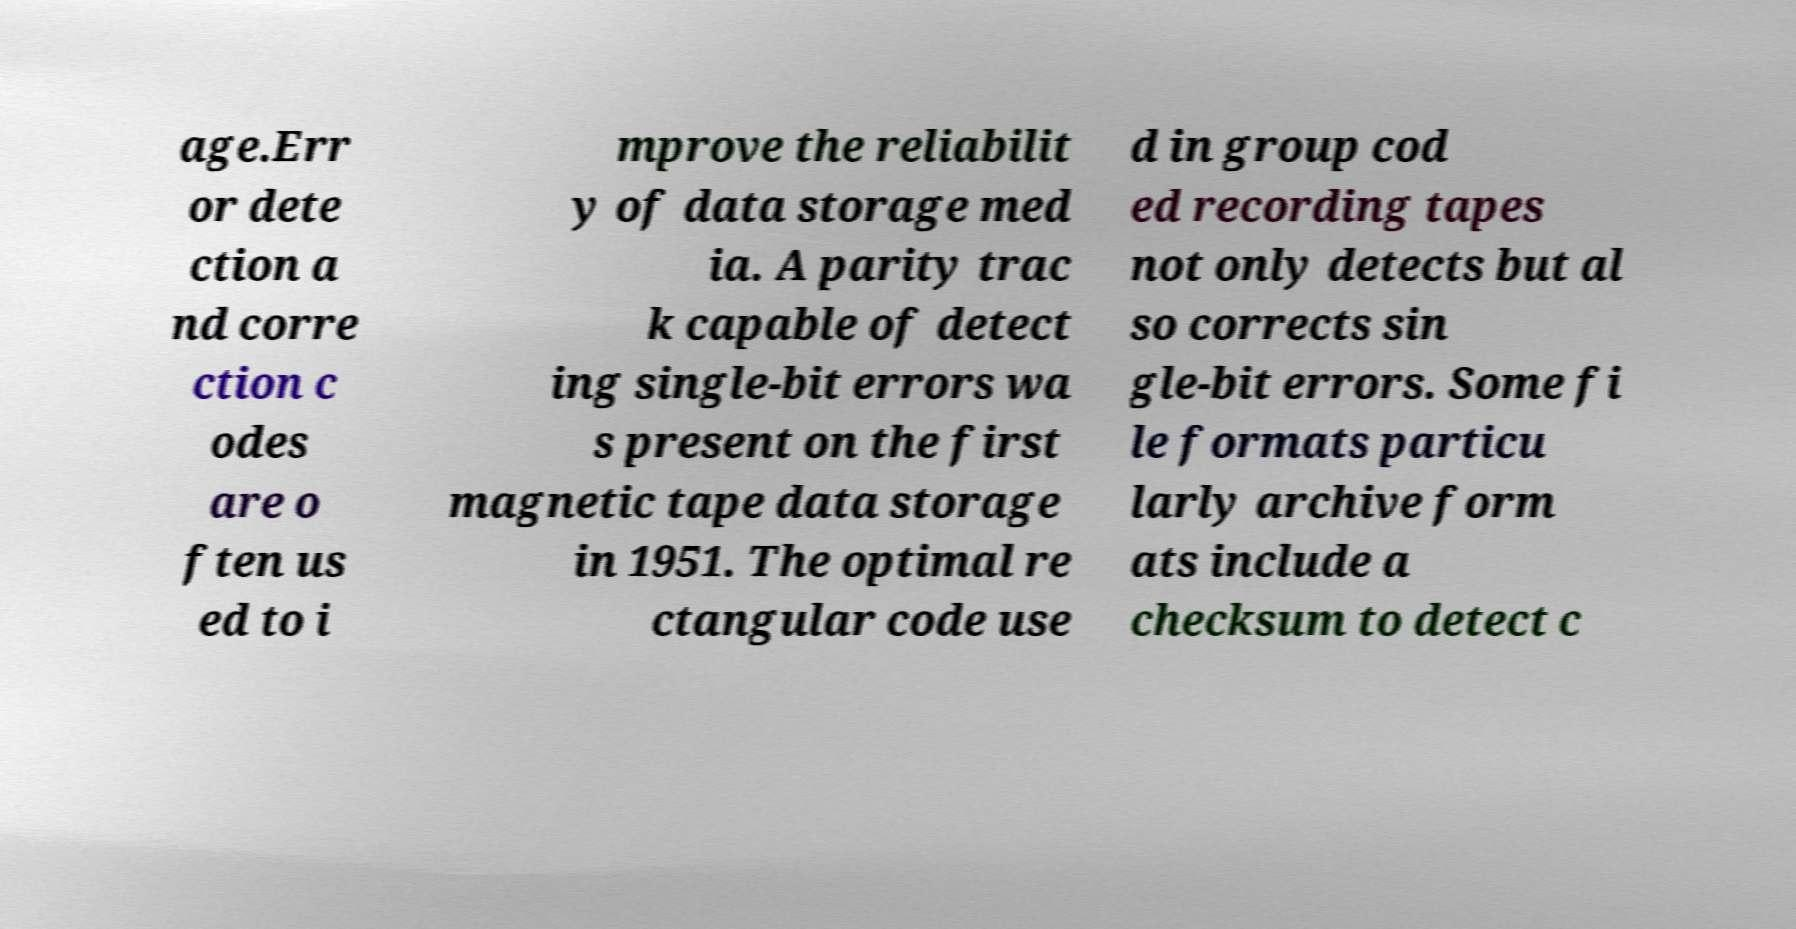I need the written content from this picture converted into text. Can you do that? age.Err or dete ction a nd corre ction c odes are o ften us ed to i mprove the reliabilit y of data storage med ia. A parity trac k capable of detect ing single-bit errors wa s present on the first magnetic tape data storage in 1951. The optimal re ctangular code use d in group cod ed recording tapes not only detects but al so corrects sin gle-bit errors. Some fi le formats particu larly archive form ats include a checksum to detect c 